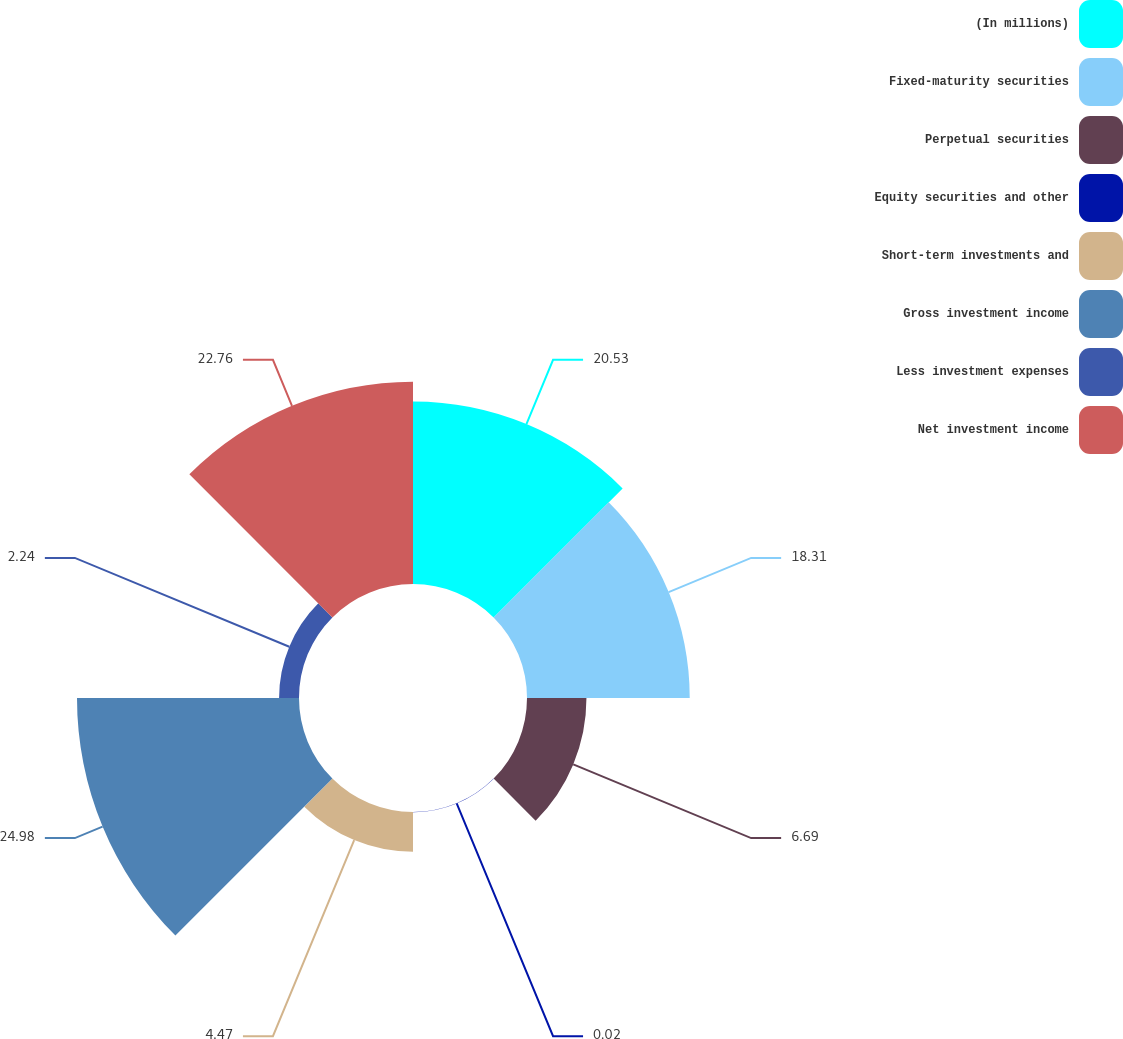<chart> <loc_0><loc_0><loc_500><loc_500><pie_chart><fcel>(In millions)<fcel>Fixed-maturity securities<fcel>Perpetual securities<fcel>Equity securities and other<fcel>Short-term investments and<fcel>Gross investment income<fcel>Less investment expenses<fcel>Net investment income<nl><fcel>20.53%<fcel>18.31%<fcel>6.69%<fcel>0.02%<fcel>4.47%<fcel>24.98%<fcel>2.24%<fcel>22.76%<nl></chart> 